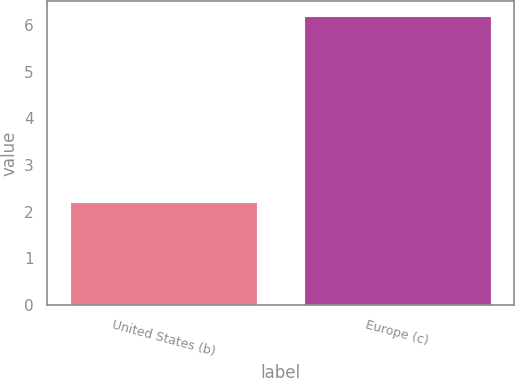Convert chart to OTSL. <chart><loc_0><loc_0><loc_500><loc_500><bar_chart><fcel>United States (b)<fcel>Europe (c)<nl><fcel>2.2<fcel>6.2<nl></chart> 